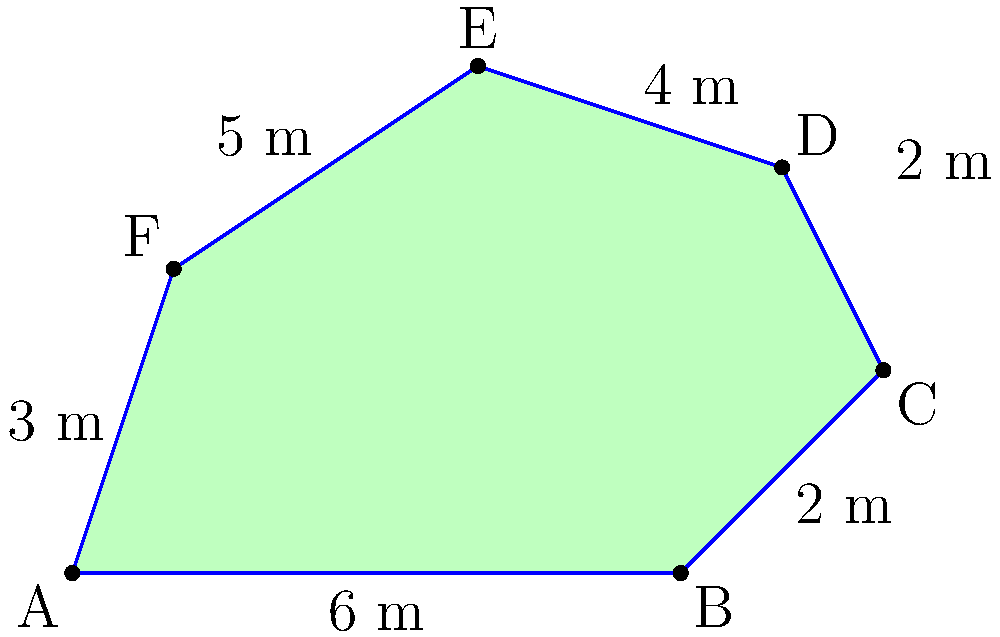As a resident of Tambon Khok Chamrae, you own an irregularly shaped rice paddy as shown in the figure. The paddy has six sides with measurements given. Calculate the total area of your rice paddy in square meters. To calculate the area of this irregular shape, we can divide it into simpler geometric shapes and sum their areas. Let's divide the paddy into a rectangle and two triangles:

1. Rectangle ABCF:
   Area = length × width = $6 \times 3 = 18$ m²

2. Triangle CDF:
   Base = 2 m, Height = 1 m
   Area = $\frac{1}{2} \times base \times height = \frac{1}{2} \times 2 \times 1 = 1$ m²

3. Triangle DEF:
   Base = 3 m, Height = 2 m
   Area = $\frac{1}{2} \times base \times height = \frac{1}{2} \times 3 \times 2 = 3$ m²

Total area = Area of rectangle + Area of triangle CDF + Area of triangle DEF
           = $18 + 1 + 3 = 22$ m²
Answer: 22 m² 